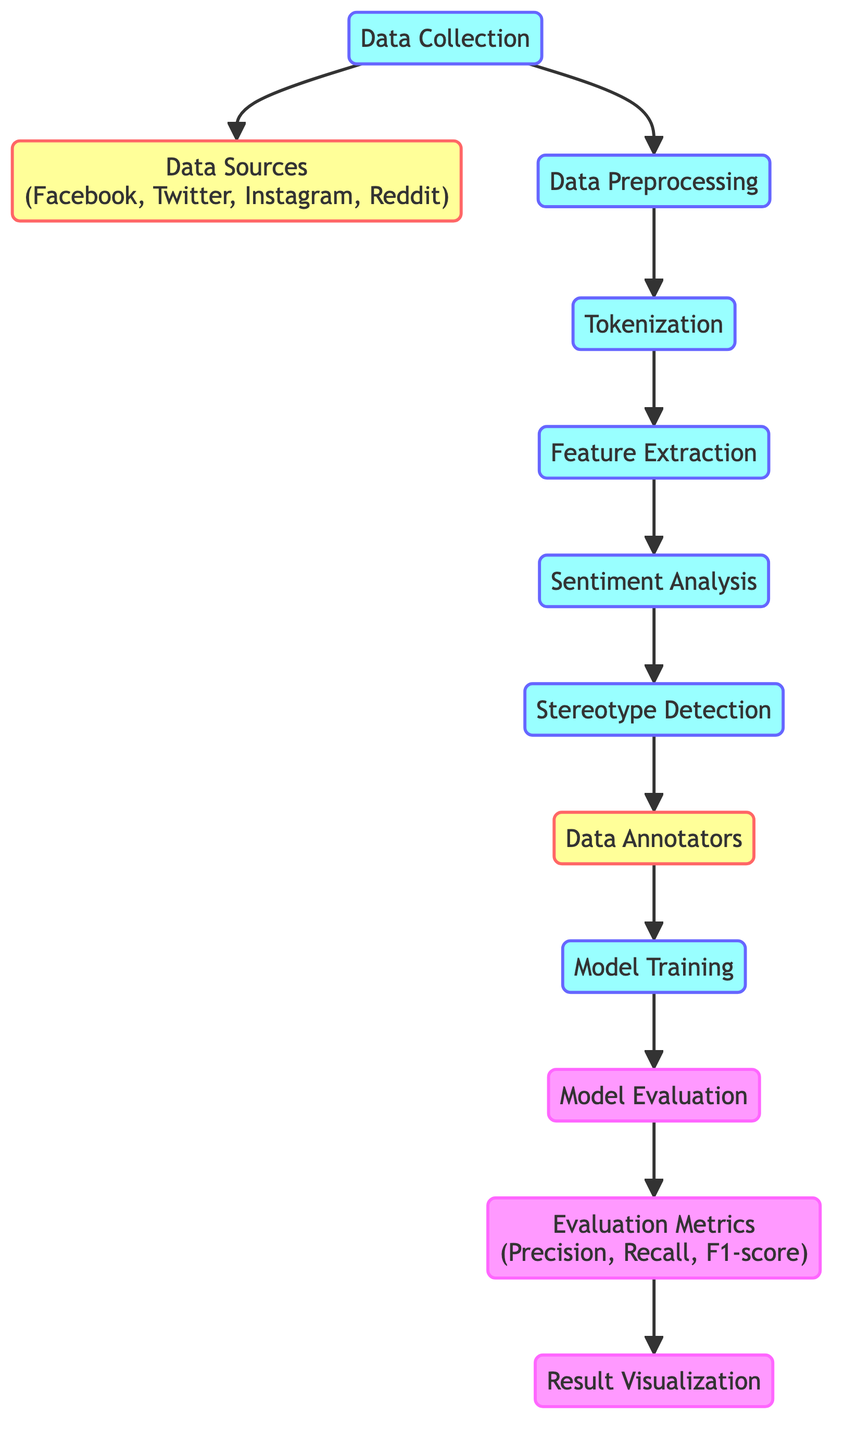What is the first process in the diagram? The first process node in the diagram is "Data Collection". It is the starting point and connects to the data sources and data preprocessing steps.
Answer: Data Collection How many data sources are mentioned in the diagram? There are four data sources mentioned in the diagram: Facebook, Twitter, Instagram, and Reddit. They are grouped together under the node labeled "Data Sources".
Answer: Four What follows after "Sentiment Analysis" in the flow? The step that follows "Sentiment Analysis" is "Stereotype Detection". This indicates the progression from analyzing sentiments to identifying stereotypes in the collected data.
Answer: Stereotype Detection What are the evaluation metrics listed in the diagram? The evaluation metrics specified in the diagram are Precision, Recall, and F1-score, which are crucial for assessing the performance of the model.
Answer: Precision, Recall, F1-score Which node involves human input in the diagram? The node that involves human input is "Data Annotators". This implies that individuals are engaged in annotating or labeling the data to enhance the training process.
Answer: Data Annotators How many processes are depicted in this diagram? There are seven processes represented in the diagram: Data Collection, Data Preprocessing, Tokenization, Feature Extraction, Sentiment Analysis, Stereotype Detection, and Model Training. These are connected by arrows indicating the workflow.
Answer: Seven What type of analysis is performed after Feature Extraction? The type of analysis performed after Feature Extraction is "Sentiment Analysis", indicating the application of methods to determine the sentiment expressed in the data.
Answer: Sentiment Analysis What is the final step in the flow of the diagram? The final step in the flow of the diagram is "Result Visualization", which indicates that after evaluating the model, the results will be visually represented for better understanding.
Answer: Result Visualization 